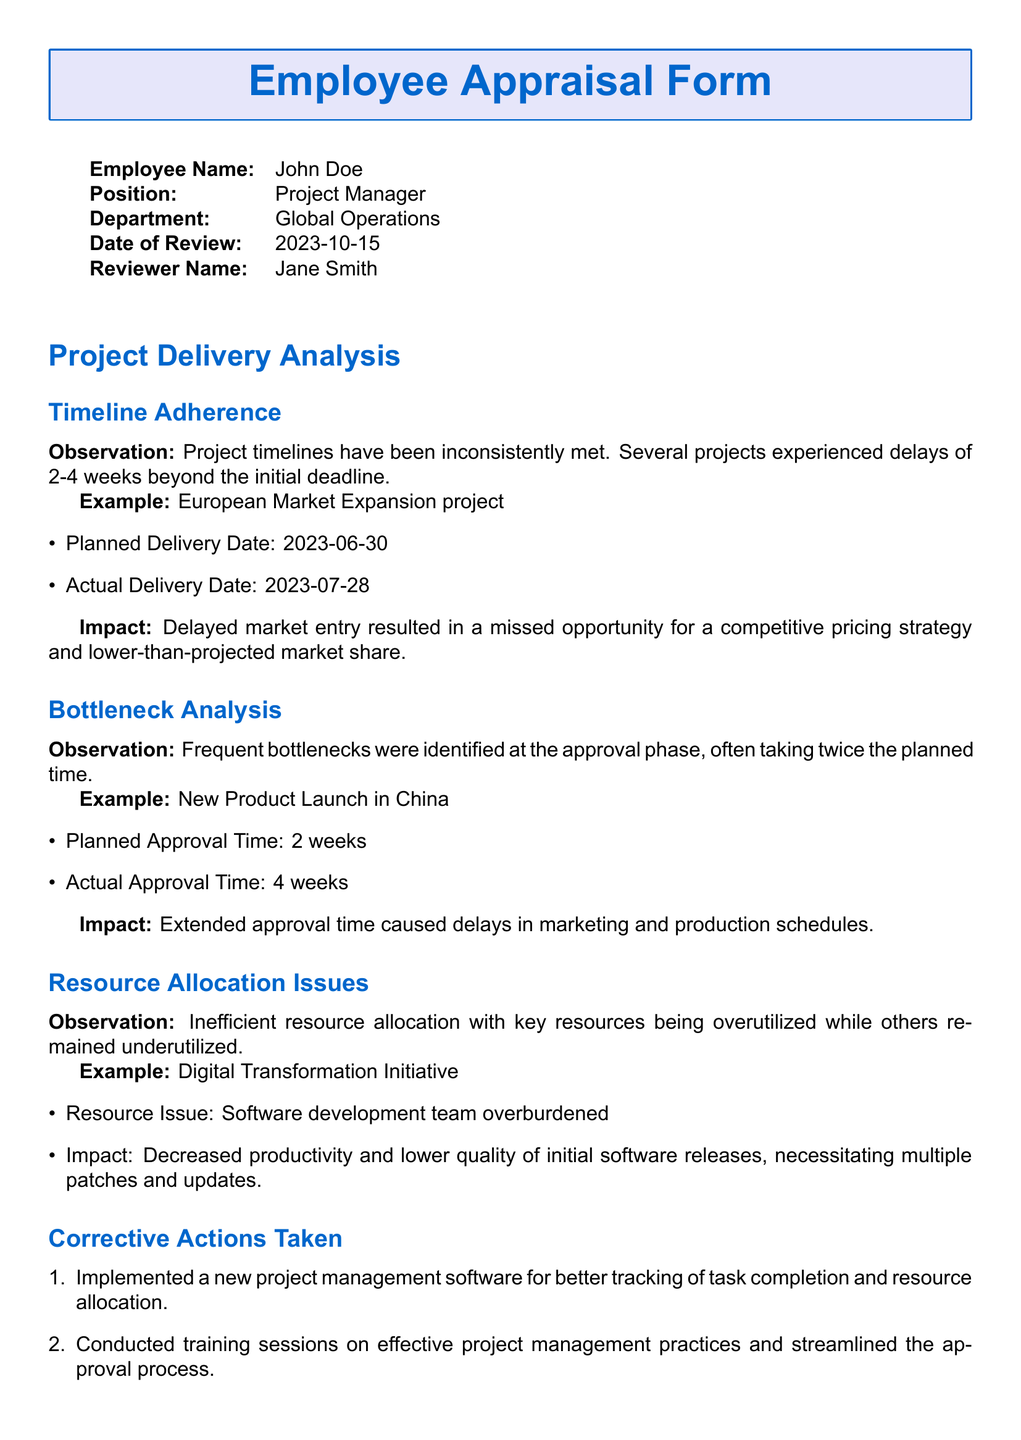What is the employee's name? The employee's name is mentioned at the top of the document, which is John Doe.
Answer: John Doe What was the planned delivery date for the European Market Expansion project? The document states the planned delivery date for this project, which is June 30, 2023.
Answer: 2023-06-30 How many weeks did the approval for the New Product Launch in China actually take? The approval time is detailed in the document where it mentions that it took 4 weeks instead of the planned 2 weeks.
Answer: 4 weeks What corrective action was taken regarding resource allocation? The document lists corrective actions, including implementing new project management software, which addresses resource allocation issues.
Answer: New project management software What was the impact of delayed project timelines mentioned in the document? The document states that delayed market entry resulted in a missed opportunity for competitive pricing and lower-than-projected market share.
Answer: Missed opportunity for competitive pricing What is the position of the employee? The position of the employee is specified in the document as Project Manager.
Answer: Project Manager How long did the Digital Transformation Initiative's resource issue impact productivity? The document indicates that key resources were overutilized, which resulted in decreased productivity; however, it does not specify a duration.
Answer: Decreased productivity What type of training sessions were conducted? The document mentions that training sessions on effective project management practices were held as a corrective action taken.
Answer: Effective project management practices 